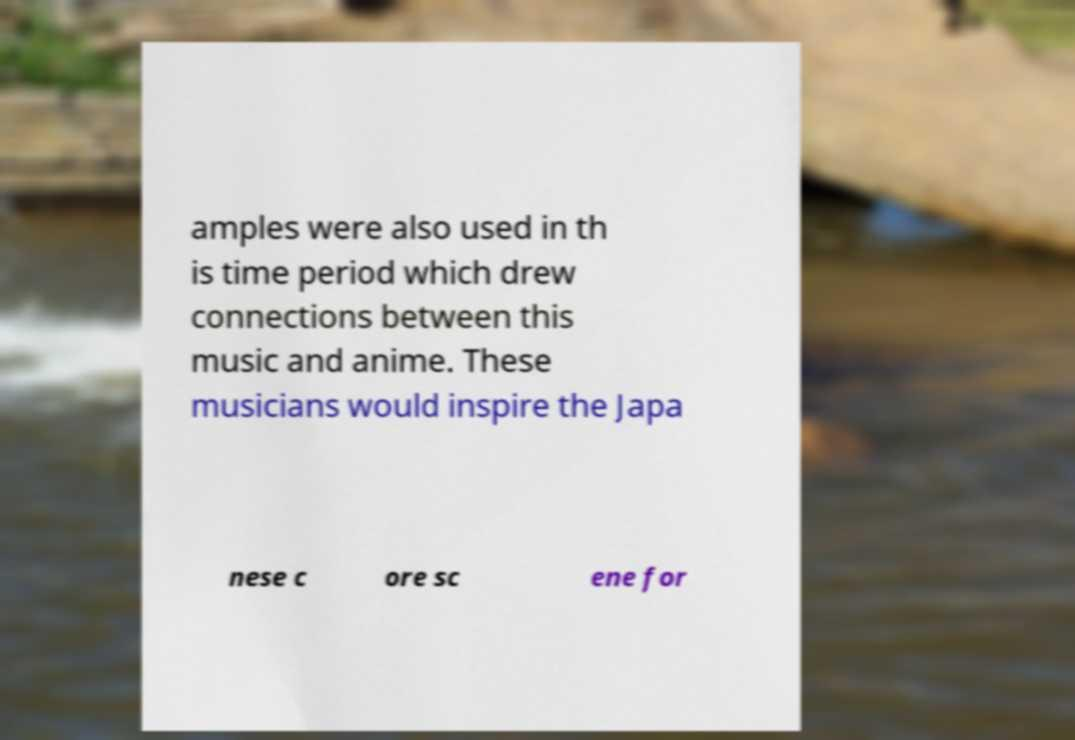What messages or text are displayed in this image? I need them in a readable, typed format. amples were also used in th is time period which drew connections between this music and anime. These musicians would inspire the Japa nese c ore sc ene for 